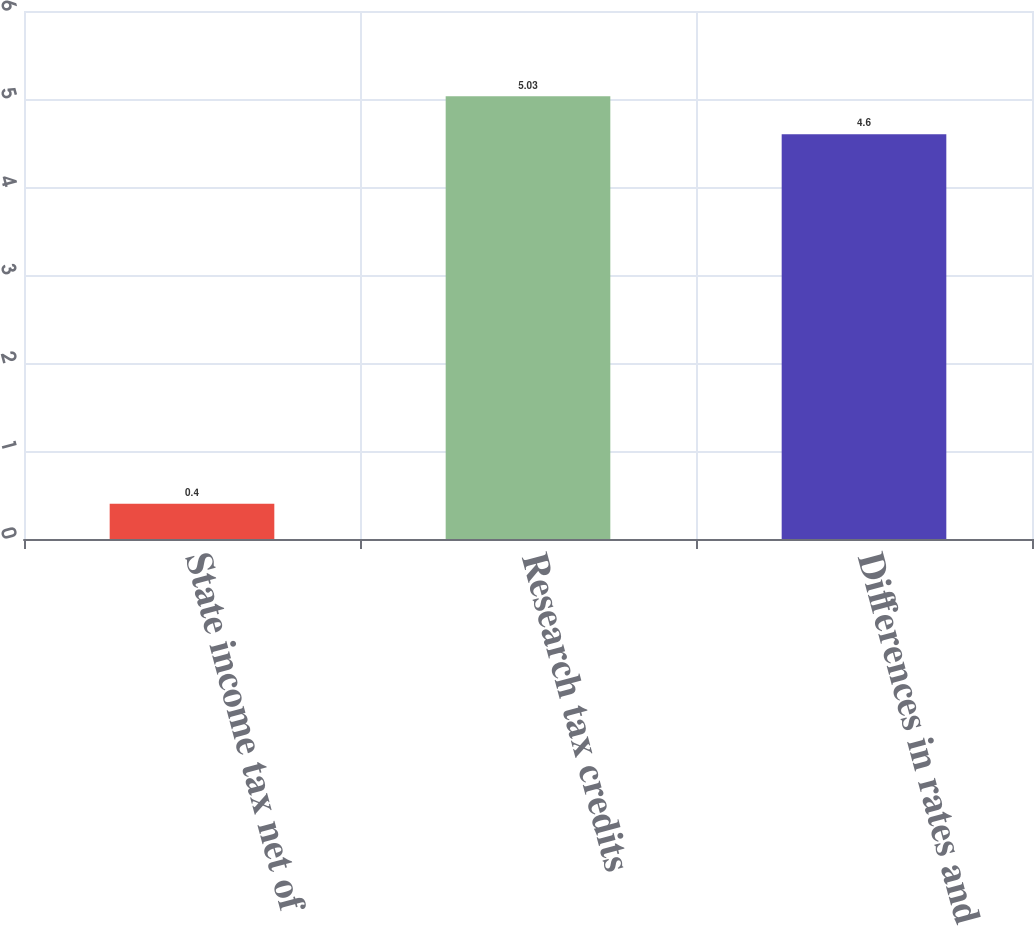Convert chart to OTSL. <chart><loc_0><loc_0><loc_500><loc_500><bar_chart><fcel>State income tax net of<fcel>Research tax credits<fcel>Differences in rates and<nl><fcel>0.4<fcel>5.03<fcel>4.6<nl></chart> 